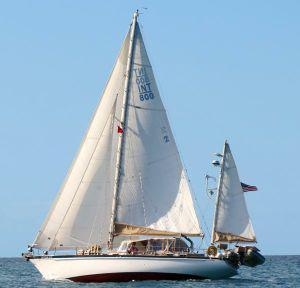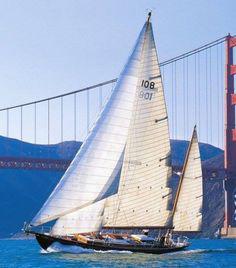The first image is the image on the left, the second image is the image on the right. Considering the images on both sides, is "There is land in the background of the image on the right." valid? Answer yes or no. Yes. 